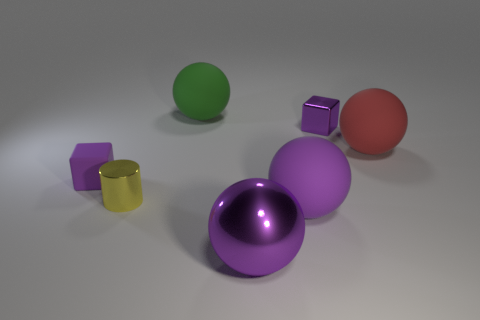Are there any purple rubber cylinders?
Keep it short and to the point. No. There is a big rubber object that is behind the cube that is behind the big red rubber object; what is its shape?
Make the answer very short. Sphere. How many objects are small cubes that are in front of the red rubber ball or big spheres that are on the left side of the small purple shiny object?
Make the answer very short. 4. There is a yellow cylinder that is the same size as the purple metallic cube; what is its material?
Your answer should be compact. Metal. What is the color of the small rubber cube?
Make the answer very short. Purple. What is the thing that is left of the shiny ball and to the right of the yellow cylinder made of?
Your answer should be compact. Rubber. There is a tiny metal object in front of the tiny object that is right of the large green object; are there any large green things on the left side of it?
Your answer should be compact. No. There is a shiny object that is the same color as the tiny shiny cube; what is its size?
Offer a terse response. Large. There is a yellow shiny cylinder; are there any large green rubber objects on the left side of it?
Keep it short and to the point. No. How many other objects are there of the same shape as the red rubber thing?
Offer a terse response. 3. 